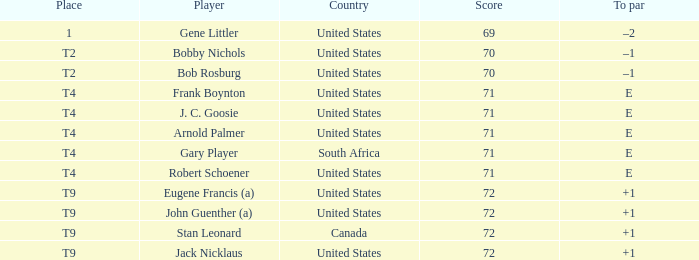What is Place, when Score is less than 70? 1.0. 